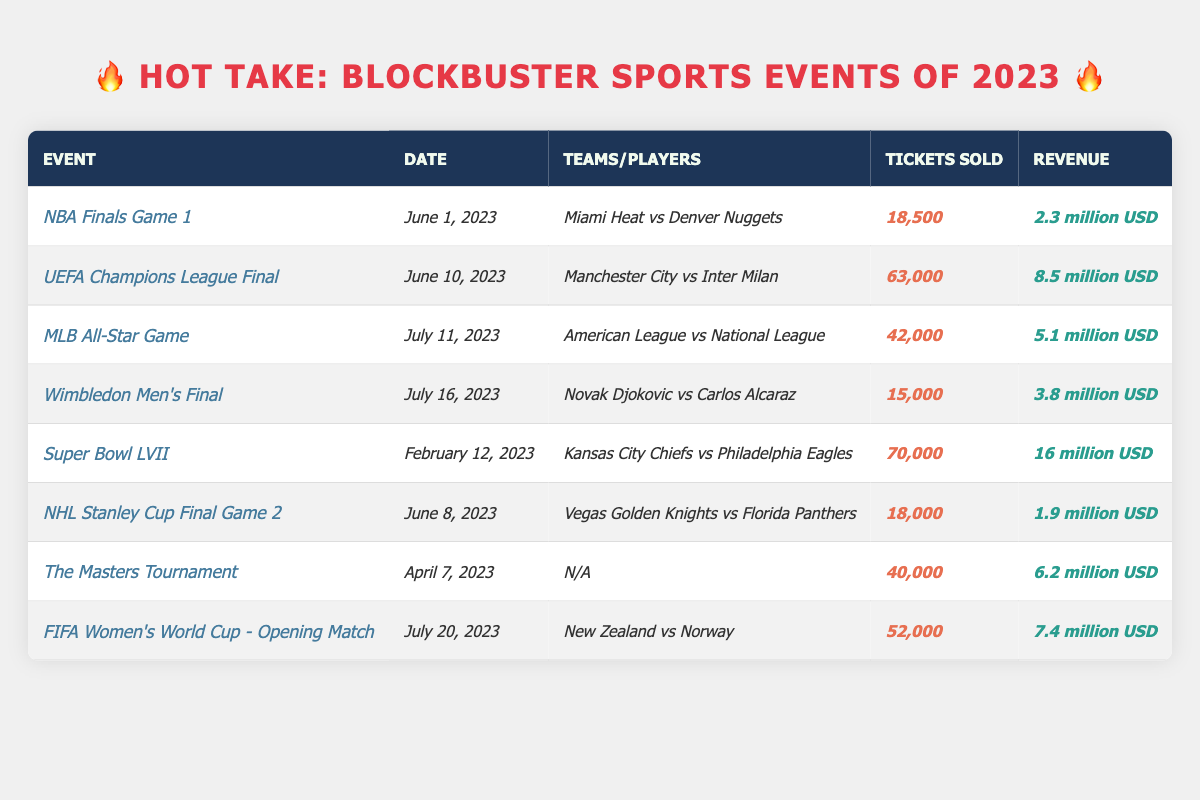What is the highest number of tickets sold for a single event? The highest number of tickets sold is associated with the *Super Bowl LVII*, where *70,000* tickets were sold.
Answer: 70,000 Which event generated the most revenue? The event with the highest revenue is the *Super Bowl LVII*, bringing in *16 million USD*.
Answer: 16 million USD How many tickets were sold for the *FIFA Women’s World Cup - Opening Match*? The *FIFA Women’s World Cup - Opening Match* had *52,000* tickets sold.
Answer: 52,000 What is the total revenue generated by all events listed? The total revenue is calculated by summing all individual revenues: *2.3m + 8.5m + 5.1m + 3.8m + 16m + 1.9m + 6.2m + 7.4m = 51.2m USD*.
Answer: 51.2 million USD Did the *NBA Finals Game 1* have more tickets sold than the *NHL Stanley Cup Final Game 2*? The *NBA Finals Game 1* sold *18,500* tickets, while the *NHL Stanley Cup Final Game 2* sold *18,000* tickets, so yes, the *NBA Finals Game 1* had more tickets sold.
Answer: Yes How many events had ticket sales above *40,000*? There are three events with ticket sales above *40,000*: the *UEFA Champions League Final* (63,000), the *MLB All-Star Game* (42,000), and the *FIFA Women’s World Cup - Opening Match* (52,000).
Answer: 3 What is the difference in revenue between the *UEFA Champions League Final* and the *NBA Finals Game 1*? The revenue for the *UEFA Champions League Final* is *8.5 million USD* and for the *NBA Finals Game 1* it is *2.3 million USD*. The difference is *8.5m - 2.3m = 6.2m USD*.
Answer: 6.2 million USD What percentage of tickets sold in the *Super Bowl LVII* compared to total tickets sold across all events? Total tickets sold are: 70,000 + 63,000 + 42,000 + 15,000 + 70,000 + 18,000 + 40,000 + 52,000 = 390,000. The percentage is (70,000 / 390,000) * 100 = 17.95%.
Answer: 17.95% Which event had the lowest ticket sales? The event with the lowest ticket sales is the *Wimbledon Men's Final*, with *15,000* tickets sold.
Answer: 15,000 Was the revenue from the *The Masters Tournament* higher than the *NHL Stanley Cup Final Game 2*? The revenue from the *The Masters Tournament* is *6.2 million USD*, while the *NHL Stanley Cup Final Game 2* generated *1.9 million USD*, so yes, *The Masters Tournament* had higher revenue.
Answer: Yes 